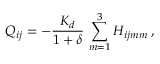Convert formula to latex. <formula><loc_0><loc_0><loc_500><loc_500>Q _ { i j } = - \frac { K _ { d } } { 1 + \delta } \, \sum _ { m = 1 } ^ { 3 } H _ { i j m m } \, ,</formula> 